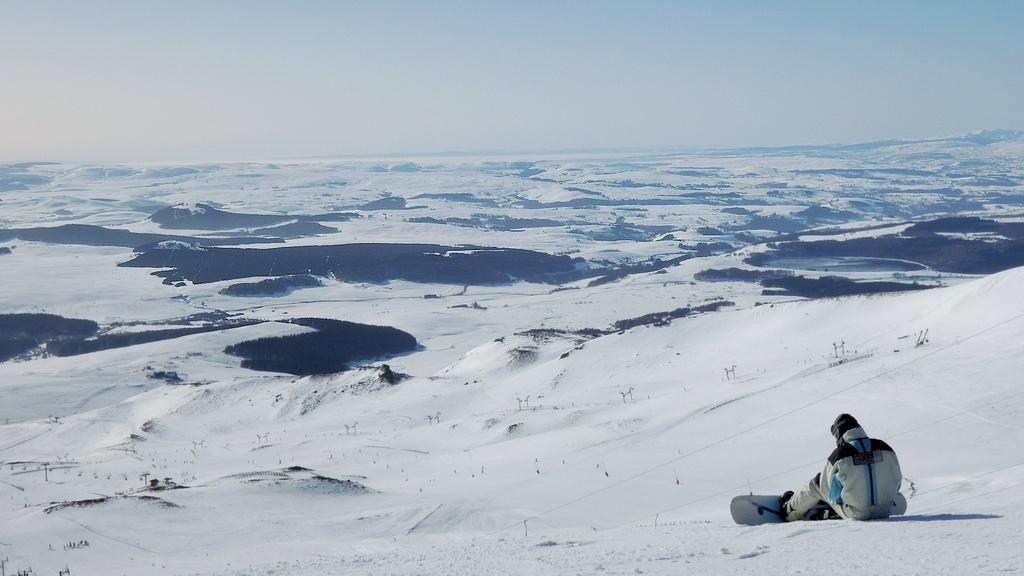What is the person in the image doing? The person is sitting on the snow. What is the person wearing that is related to snow? The person is wearing a snowboard. What type of environment is visible in the image? There is snow visible in the background, and the sky is visible in the background as well. Can you describe the wound on the person's arm in the image? There is no wound visible on the person's arm in the image. 